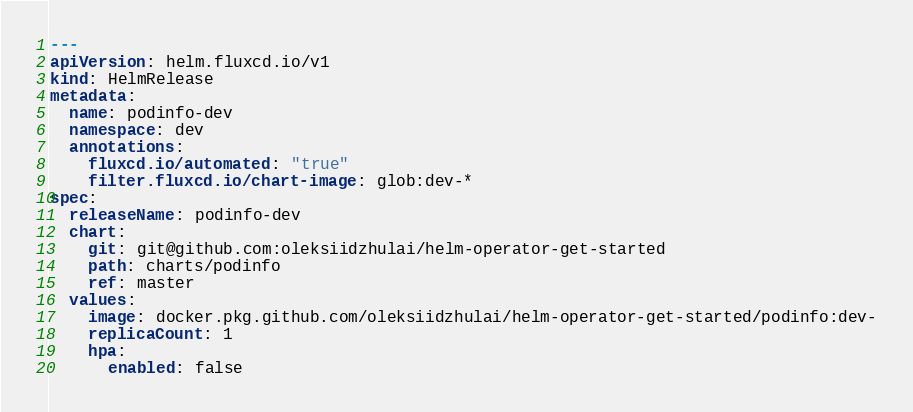<code> <loc_0><loc_0><loc_500><loc_500><_YAML_>---
apiVersion: helm.fluxcd.io/v1
kind: HelmRelease
metadata:
  name: podinfo-dev
  namespace: dev
  annotations:
    fluxcd.io/automated: "true"
    filter.fluxcd.io/chart-image: glob:dev-*
spec:
  releaseName: podinfo-dev
  chart:
    git: git@github.com:oleksiidzhulai/helm-operator-get-started
    path: charts/podinfo
    ref: master
  values:
    image: docker.pkg.github.com/oleksiidzhulai/helm-operator-get-started/podinfo:dev-
    replicaCount: 1
    hpa:
      enabled: false
</code> 